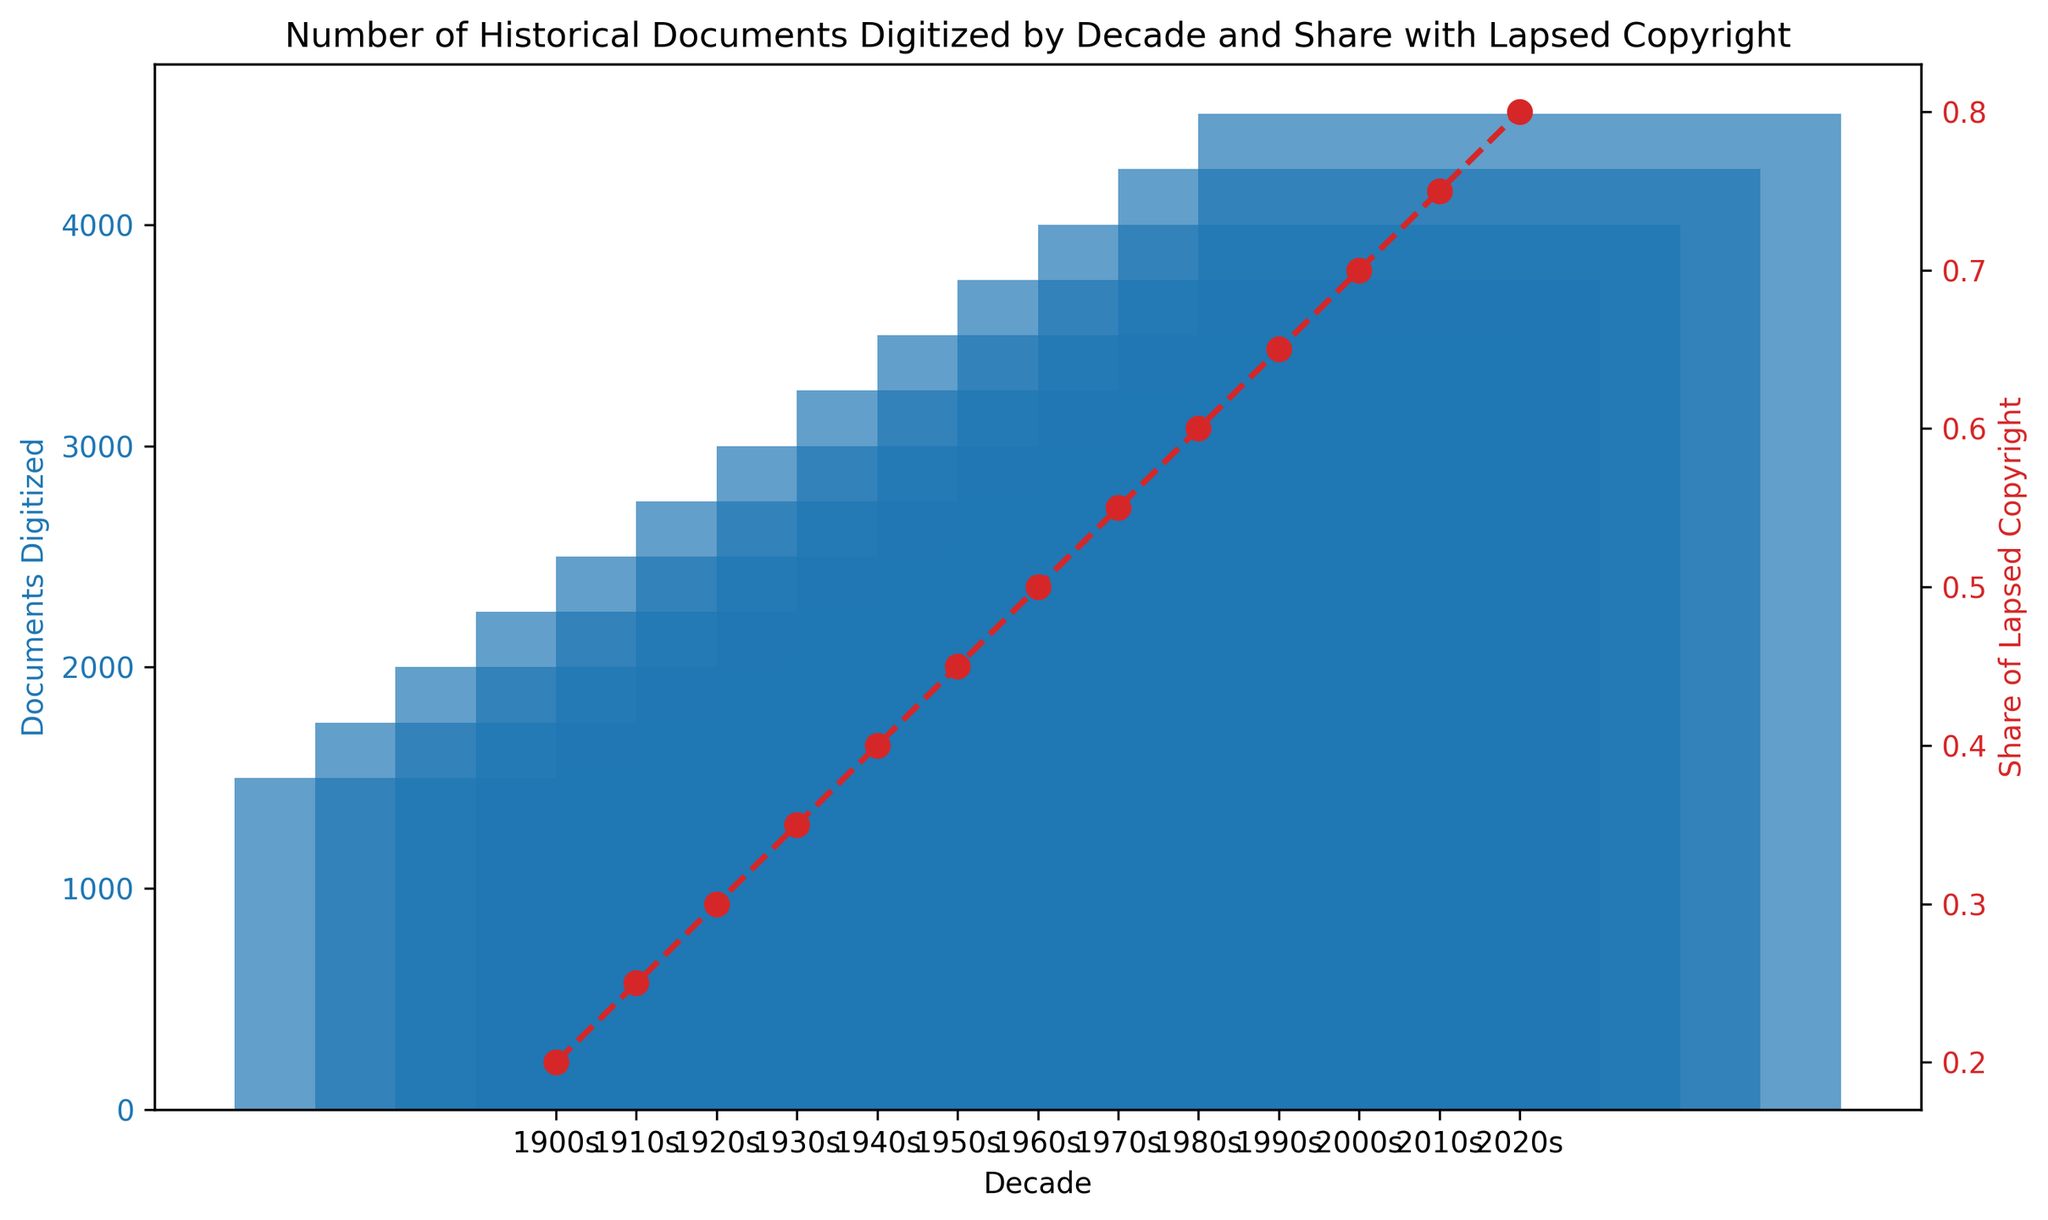What is the decade with the highest number of digitized documents? Look at the highest bar in the bar chart. The tallest bar corresponds to the 2020s.
Answer: 2020s Which decade has a higher share of lapsed copyright documents, the 1960s or the 1990s? Locate the points on the line graph for both the 1960s and the 1990s and compare their heights. The 1990s (0.65) have a higher share of lapsed copyright documents than the 1960s (0.50).
Answer: 1990s What is the difference in the number of documents digitized between the 1980s and 2000s? Look at the heights of the bars for the 1980s and the 2000s and subtract the value for the 1980s from the 2000s. 4000 - 3500 = 500.
Answer: 500 In which decade did the share of lapsed copyright documents reach 0.5? Identify the point on the line graph where the value reaches 0.5. This occurs in the 1960s.
Answer: 1960s How has the number of documents digitized changed from the 1900s to the 2020s? Compare the heights of the first bar (1900s) and last bar (2020s) to see the overall trend. The number increased from 1500 to 4500, showing a steady rise.
Answer: Increased What is the average number of documents digitized per decade from the 1900s to the 1950s? Sum the values for the 1900s, 1910s, 1920s, 1930s, 1940s and 1950s, then divide by 6. (1500 + 1750 + 2000 + 2250 + 2500 + 2750) / 6 = 2125.
Answer: 2125 Which decade shows an equal share of lapsed copyright documents and digitized documents volume multiple (in units of thousands)? Compare the share of lapsed copyright line values with the corresponding digitized document columns divided by 1000. The 0.2 share in the 1900s equals 1500/1000 digits, and 2010s and 2020s get closest values but not matches.
Answer: None What is the trend in the share of lapsed copyright documents over the decades? Observe the line graph pattern to see if values generally increase or decrease. The share consistently increases from 0.2 in the 1900s to 0.8 in the 2020s, indicating a rising trend.
Answer: Increasing 